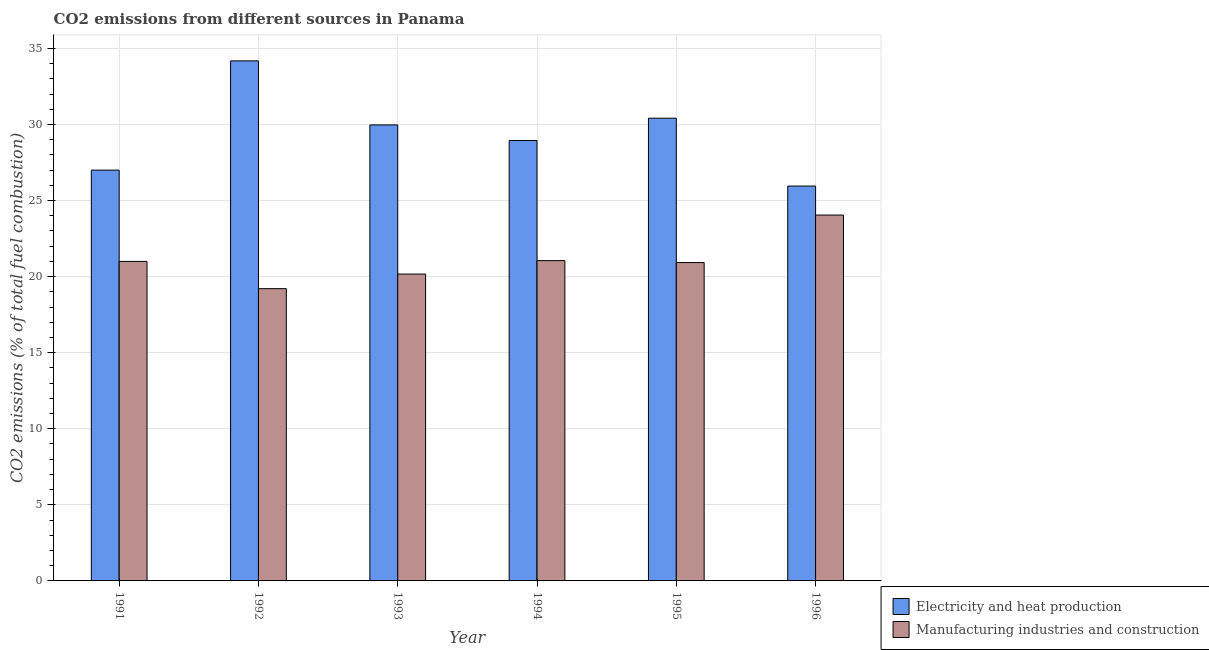Are the number of bars per tick equal to the number of legend labels?
Your answer should be very brief. Yes. Are the number of bars on each tick of the X-axis equal?
Ensure brevity in your answer.  Yes. What is the label of the 5th group of bars from the left?
Give a very brief answer. 1995. In how many cases, is the number of bars for a given year not equal to the number of legend labels?
Provide a short and direct response. 0. What is the co2 emissions due to electricity and heat production in 1991?
Provide a succinct answer. 27. Across all years, what is the maximum co2 emissions due to manufacturing industries?
Your answer should be very brief. 24.05. Across all years, what is the minimum co2 emissions due to electricity and heat production?
Offer a very short reply. 25.95. In which year was the co2 emissions due to manufacturing industries maximum?
Make the answer very short. 1996. What is the total co2 emissions due to manufacturing industries in the graph?
Ensure brevity in your answer.  126.4. What is the difference between the co2 emissions due to electricity and heat production in 1991 and that in 1993?
Keep it short and to the point. -2.97. What is the difference between the co2 emissions due to electricity and heat production in 1991 and the co2 emissions due to manufacturing industries in 1995?
Ensure brevity in your answer.  -3.41. What is the average co2 emissions due to manufacturing industries per year?
Make the answer very short. 21.07. In the year 1992, what is the difference between the co2 emissions due to electricity and heat production and co2 emissions due to manufacturing industries?
Give a very brief answer. 0. What is the ratio of the co2 emissions due to manufacturing industries in 1991 to that in 1995?
Offer a terse response. 1. What is the difference between the highest and the second highest co2 emissions due to manufacturing industries?
Ensure brevity in your answer.  2.99. What is the difference between the highest and the lowest co2 emissions due to manufacturing industries?
Offer a terse response. 4.84. In how many years, is the co2 emissions due to electricity and heat production greater than the average co2 emissions due to electricity and heat production taken over all years?
Keep it short and to the point. 3. What does the 1st bar from the left in 1993 represents?
Make the answer very short. Electricity and heat production. What does the 2nd bar from the right in 1991 represents?
Offer a very short reply. Electricity and heat production. How many bars are there?
Ensure brevity in your answer.  12. How many years are there in the graph?
Your answer should be compact. 6. What is the difference between two consecutive major ticks on the Y-axis?
Provide a short and direct response. 5. Are the values on the major ticks of Y-axis written in scientific E-notation?
Keep it short and to the point. No. Does the graph contain any zero values?
Your answer should be compact. No. Where does the legend appear in the graph?
Offer a terse response. Bottom right. How many legend labels are there?
Provide a short and direct response. 2. What is the title of the graph?
Make the answer very short. CO2 emissions from different sources in Panama. Does "Primary school" appear as one of the legend labels in the graph?
Ensure brevity in your answer.  No. What is the label or title of the X-axis?
Provide a short and direct response. Year. What is the label or title of the Y-axis?
Give a very brief answer. CO2 emissions (% of total fuel combustion). What is the CO2 emissions (% of total fuel combustion) of Electricity and heat production in 1991?
Keep it short and to the point. 27. What is the CO2 emissions (% of total fuel combustion) in Electricity and heat production in 1992?
Your answer should be compact. 34.18. What is the CO2 emissions (% of total fuel combustion) in Manufacturing industries and construction in 1992?
Offer a very short reply. 19.21. What is the CO2 emissions (% of total fuel combustion) of Electricity and heat production in 1993?
Provide a short and direct response. 29.97. What is the CO2 emissions (% of total fuel combustion) of Manufacturing industries and construction in 1993?
Keep it short and to the point. 20.17. What is the CO2 emissions (% of total fuel combustion) in Electricity and heat production in 1994?
Your response must be concise. 28.95. What is the CO2 emissions (% of total fuel combustion) in Manufacturing industries and construction in 1994?
Provide a succinct answer. 21.05. What is the CO2 emissions (% of total fuel combustion) in Electricity and heat production in 1995?
Ensure brevity in your answer.  30.41. What is the CO2 emissions (% of total fuel combustion) of Manufacturing industries and construction in 1995?
Your answer should be compact. 20.92. What is the CO2 emissions (% of total fuel combustion) of Electricity and heat production in 1996?
Your answer should be very brief. 25.95. What is the CO2 emissions (% of total fuel combustion) of Manufacturing industries and construction in 1996?
Give a very brief answer. 24.05. Across all years, what is the maximum CO2 emissions (% of total fuel combustion) of Electricity and heat production?
Your answer should be compact. 34.18. Across all years, what is the maximum CO2 emissions (% of total fuel combustion) in Manufacturing industries and construction?
Offer a terse response. 24.05. Across all years, what is the minimum CO2 emissions (% of total fuel combustion) of Electricity and heat production?
Your answer should be very brief. 25.95. Across all years, what is the minimum CO2 emissions (% of total fuel combustion) of Manufacturing industries and construction?
Give a very brief answer. 19.21. What is the total CO2 emissions (% of total fuel combustion) of Electricity and heat production in the graph?
Provide a succinct answer. 176.47. What is the total CO2 emissions (% of total fuel combustion) in Manufacturing industries and construction in the graph?
Your response must be concise. 126.4. What is the difference between the CO2 emissions (% of total fuel combustion) in Electricity and heat production in 1991 and that in 1992?
Your answer should be very brief. -7.18. What is the difference between the CO2 emissions (% of total fuel combustion) in Manufacturing industries and construction in 1991 and that in 1992?
Offer a very short reply. 1.79. What is the difference between the CO2 emissions (% of total fuel combustion) of Electricity and heat production in 1991 and that in 1993?
Keep it short and to the point. -2.97. What is the difference between the CO2 emissions (% of total fuel combustion) of Manufacturing industries and construction in 1991 and that in 1993?
Provide a succinct answer. 0.83. What is the difference between the CO2 emissions (% of total fuel combustion) of Electricity and heat production in 1991 and that in 1994?
Provide a succinct answer. -1.95. What is the difference between the CO2 emissions (% of total fuel combustion) of Manufacturing industries and construction in 1991 and that in 1994?
Offer a terse response. -0.05. What is the difference between the CO2 emissions (% of total fuel combustion) of Electricity and heat production in 1991 and that in 1995?
Your answer should be compact. -3.41. What is the difference between the CO2 emissions (% of total fuel combustion) in Manufacturing industries and construction in 1991 and that in 1995?
Give a very brief answer. 0.08. What is the difference between the CO2 emissions (% of total fuel combustion) of Electricity and heat production in 1991 and that in 1996?
Offer a terse response. 1.05. What is the difference between the CO2 emissions (% of total fuel combustion) of Manufacturing industries and construction in 1991 and that in 1996?
Provide a short and direct response. -3.05. What is the difference between the CO2 emissions (% of total fuel combustion) of Electricity and heat production in 1992 and that in 1993?
Give a very brief answer. 4.21. What is the difference between the CO2 emissions (% of total fuel combustion) of Manufacturing industries and construction in 1992 and that in 1993?
Keep it short and to the point. -0.96. What is the difference between the CO2 emissions (% of total fuel combustion) in Electricity and heat production in 1992 and that in 1994?
Your answer should be compact. 5.23. What is the difference between the CO2 emissions (% of total fuel combustion) in Manufacturing industries and construction in 1992 and that in 1994?
Ensure brevity in your answer.  -1.84. What is the difference between the CO2 emissions (% of total fuel combustion) in Electricity and heat production in 1992 and that in 1995?
Keep it short and to the point. 3.77. What is the difference between the CO2 emissions (% of total fuel combustion) of Manufacturing industries and construction in 1992 and that in 1995?
Ensure brevity in your answer.  -1.72. What is the difference between the CO2 emissions (% of total fuel combustion) of Electricity and heat production in 1992 and that in 1996?
Your response must be concise. 8.23. What is the difference between the CO2 emissions (% of total fuel combustion) in Manufacturing industries and construction in 1992 and that in 1996?
Offer a terse response. -4.84. What is the difference between the CO2 emissions (% of total fuel combustion) in Electricity and heat production in 1993 and that in 1994?
Offer a terse response. 1.02. What is the difference between the CO2 emissions (% of total fuel combustion) of Manufacturing industries and construction in 1993 and that in 1994?
Offer a terse response. -0.88. What is the difference between the CO2 emissions (% of total fuel combustion) of Electricity and heat production in 1993 and that in 1995?
Your answer should be very brief. -0.44. What is the difference between the CO2 emissions (% of total fuel combustion) of Manufacturing industries and construction in 1993 and that in 1995?
Your response must be concise. -0.76. What is the difference between the CO2 emissions (% of total fuel combustion) of Electricity and heat production in 1993 and that in 1996?
Your answer should be very brief. 4.02. What is the difference between the CO2 emissions (% of total fuel combustion) of Manufacturing industries and construction in 1993 and that in 1996?
Ensure brevity in your answer.  -3.88. What is the difference between the CO2 emissions (% of total fuel combustion) in Electricity and heat production in 1994 and that in 1995?
Make the answer very short. -1.47. What is the difference between the CO2 emissions (% of total fuel combustion) of Manufacturing industries and construction in 1994 and that in 1995?
Offer a terse response. 0.13. What is the difference between the CO2 emissions (% of total fuel combustion) of Electricity and heat production in 1994 and that in 1996?
Your answer should be compact. 3. What is the difference between the CO2 emissions (% of total fuel combustion) in Manufacturing industries and construction in 1994 and that in 1996?
Keep it short and to the point. -3. What is the difference between the CO2 emissions (% of total fuel combustion) in Electricity and heat production in 1995 and that in 1996?
Offer a very short reply. 4.46. What is the difference between the CO2 emissions (% of total fuel combustion) in Manufacturing industries and construction in 1995 and that in 1996?
Provide a short and direct response. -3.12. What is the difference between the CO2 emissions (% of total fuel combustion) in Electricity and heat production in 1991 and the CO2 emissions (% of total fuel combustion) in Manufacturing industries and construction in 1992?
Provide a short and direct response. 7.79. What is the difference between the CO2 emissions (% of total fuel combustion) of Electricity and heat production in 1991 and the CO2 emissions (% of total fuel combustion) of Manufacturing industries and construction in 1993?
Your answer should be compact. 6.83. What is the difference between the CO2 emissions (% of total fuel combustion) of Electricity and heat production in 1991 and the CO2 emissions (% of total fuel combustion) of Manufacturing industries and construction in 1994?
Your answer should be compact. 5.95. What is the difference between the CO2 emissions (% of total fuel combustion) of Electricity and heat production in 1991 and the CO2 emissions (% of total fuel combustion) of Manufacturing industries and construction in 1995?
Your response must be concise. 6.08. What is the difference between the CO2 emissions (% of total fuel combustion) in Electricity and heat production in 1991 and the CO2 emissions (% of total fuel combustion) in Manufacturing industries and construction in 1996?
Provide a succinct answer. 2.95. What is the difference between the CO2 emissions (% of total fuel combustion) in Electricity and heat production in 1992 and the CO2 emissions (% of total fuel combustion) in Manufacturing industries and construction in 1993?
Keep it short and to the point. 14.01. What is the difference between the CO2 emissions (% of total fuel combustion) in Electricity and heat production in 1992 and the CO2 emissions (% of total fuel combustion) in Manufacturing industries and construction in 1994?
Your answer should be very brief. 13.13. What is the difference between the CO2 emissions (% of total fuel combustion) of Electricity and heat production in 1992 and the CO2 emissions (% of total fuel combustion) of Manufacturing industries and construction in 1995?
Give a very brief answer. 13.26. What is the difference between the CO2 emissions (% of total fuel combustion) of Electricity and heat production in 1992 and the CO2 emissions (% of total fuel combustion) of Manufacturing industries and construction in 1996?
Provide a short and direct response. 10.13. What is the difference between the CO2 emissions (% of total fuel combustion) of Electricity and heat production in 1993 and the CO2 emissions (% of total fuel combustion) of Manufacturing industries and construction in 1994?
Ensure brevity in your answer.  8.92. What is the difference between the CO2 emissions (% of total fuel combustion) of Electricity and heat production in 1993 and the CO2 emissions (% of total fuel combustion) of Manufacturing industries and construction in 1995?
Make the answer very short. 9.05. What is the difference between the CO2 emissions (% of total fuel combustion) in Electricity and heat production in 1993 and the CO2 emissions (% of total fuel combustion) in Manufacturing industries and construction in 1996?
Make the answer very short. 5.92. What is the difference between the CO2 emissions (% of total fuel combustion) in Electricity and heat production in 1994 and the CO2 emissions (% of total fuel combustion) in Manufacturing industries and construction in 1995?
Provide a succinct answer. 8.02. What is the difference between the CO2 emissions (% of total fuel combustion) in Electricity and heat production in 1994 and the CO2 emissions (% of total fuel combustion) in Manufacturing industries and construction in 1996?
Provide a succinct answer. 4.9. What is the difference between the CO2 emissions (% of total fuel combustion) of Electricity and heat production in 1995 and the CO2 emissions (% of total fuel combustion) of Manufacturing industries and construction in 1996?
Your answer should be very brief. 6.37. What is the average CO2 emissions (% of total fuel combustion) in Electricity and heat production per year?
Offer a very short reply. 29.41. What is the average CO2 emissions (% of total fuel combustion) of Manufacturing industries and construction per year?
Your answer should be compact. 21.07. In the year 1991, what is the difference between the CO2 emissions (% of total fuel combustion) in Electricity and heat production and CO2 emissions (% of total fuel combustion) in Manufacturing industries and construction?
Your answer should be compact. 6. In the year 1992, what is the difference between the CO2 emissions (% of total fuel combustion) in Electricity and heat production and CO2 emissions (% of total fuel combustion) in Manufacturing industries and construction?
Ensure brevity in your answer.  14.97. In the year 1993, what is the difference between the CO2 emissions (% of total fuel combustion) in Electricity and heat production and CO2 emissions (% of total fuel combustion) in Manufacturing industries and construction?
Provide a succinct answer. 9.8. In the year 1994, what is the difference between the CO2 emissions (% of total fuel combustion) in Electricity and heat production and CO2 emissions (% of total fuel combustion) in Manufacturing industries and construction?
Provide a short and direct response. 7.89. In the year 1995, what is the difference between the CO2 emissions (% of total fuel combustion) in Electricity and heat production and CO2 emissions (% of total fuel combustion) in Manufacturing industries and construction?
Offer a terse response. 9.49. In the year 1996, what is the difference between the CO2 emissions (% of total fuel combustion) in Electricity and heat production and CO2 emissions (% of total fuel combustion) in Manufacturing industries and construction?
Your response must be concise. 1.9. What is the ratio of the CO2 emissions (% of total fuel combustion) of Electricity and heat production in 1991 to that in 1992?
Offer a terse response. 0.79. What is the ratio of the CO2 emissions (% of total fuel combustion) of Manufacturing industries and construction in 1991 to that in 1992?
Ensure brevity in your answer.  1.09. What is the ratio of the CO2 emissions (% of total fuel combustion) in Electricity and heat production in 1991 to that in 1993?
Make the answer very short. 0.9. What is the ratio of the CO2 emissions (% of total fuel combustion) of Manufacturing industries and construction in 1991 to that in 1993?
Offer a very short reply. 1.04. What is the ratio of the CO2 emissions (% of total fuel combustion) of Electricity and heat production in 1991 to that in 1994?
Offer a very short reply. 0.93. What is the ratio of the CO2 emissions (% of total fuel combustion) of Electricity and heat production in 1991 to that in 1995?
Offer a very short reply. 0.89. What is the ratio of the CO2 emissions (% of total fuel combustion) of Manufacturing industries and construction in 1991 to that in 1995?
Your answer should be very brief. 1. What is the ratio of the CO2 emissions (% of total fuel combustion) in Electricity and heat production in 1991 to that in 1996?
Give a very brief answer. 1.04. What is the ratio of the CO2 emissions (% of total fuel combustion) of Manufacturing industries and construction in 1991 to that in 1996?
Ensure brevity in your answer.  0.87. What is the ratio of the CO2 emissions (% of total fuel combustion) in Electricity and heat production in 1992 to that in 1993?
Your response must be concise. 1.14. What is the ratio of the CO2 emissions (% of total fuel combustion) in Electricity and heat production in 1992 to that in 1994?
Provide a succinct answer. 1.18. What is the ratio of the CO2 emissions (% of total fuel combustion) in Manufacturing industries and construction in 1992 to that in 1994?
Provide a short and direct response. 0.91. What is the ratio of the CO2 emissions (% of total fuel combustion) in Electricity and heat production in 1992 to that in 1995?
Your answer should be very brief. 1.12. What is the ratio of the CO2 emissions (% of total fuel combustion) of Manufacturing industries and construction in 1992 to that in 1995?
Your answer should be compact. 0.92. What is the ratio of the CO2 emissions (% of total fuel combustion) of Electricity and heat production in 1992 to that in 1996?
Offer a very short reply. 1.32. What is the ratio of the CO2 emissions (% of total fuel combustion) of Manufacturing industries and construction in 1992 to that in 1996?
Your response must be concise. 0.8. What is the ratio of the CO2 emissions (% of total fuel combustion) of Electricity and heat production in 1993 to that in 1994?
Ensure brevity in your answer.  1.04. What is the ratio of the CO2 emissions (% of total fuel combustion) in Manufacturing industries and construction in 1993 to that in 1994?
Offer a terse response. 0.96. What is the ratio of the CO2 emissions (% of total fuel combustion) of Electricity and heat production in 1993 to that in 1995?
Your answer should be compact. 0.99. What is the ratio of the CO2 emissions (% of total fuel combustion) of Manufacturing industries and construction in 1993 to that in 1995?
Provide a short and direct response. 0.96. What is the ratio of the CO2 emissions (% of total fuel combustion) of Electricity and heat production in 1993 to that in 1996?
Provide a succinct answer. 1.15. What is the ratio of the CO2 emissions (% of total fuel combustion) of Manufacturing industries and construction in 1993 to that in 1996?
Offer a very short reply. 0.84. What is the ratio of the CO2 emissions (% of total fuel combustion) of Electricity and heat production in 1994 to that in 1995?
Your response must be concise. 0.95. What is the ratio of the CO2 emissions (% of total fuel combustion) of Manufacturing industries and construction in 1994 to that in 1995?
Ensure brevity in your answer.  1.01. What is the ratio of the CO2 emissions (% of total fuel combustion) of Electricity and heat production in 1994 to that in 1996?
Provide a short and direct response. 1.12. What is the ratio of the CO2 emissions (% of total fuel combustion) in Manufacturing industries and construction in 1994 to that in 1996?
Provide a short and direct response. 0.88. What is the ratio of the CO2 emissions (% of total fuel combustion) of Electricity and heat production in 1995 to that in 1996?
Ensure brevity in your answer.  1.17. What is the ratio of the CO2 emissions (% of total fuel combustion) of Manufacturing industries and construction in 1995 to that in 1996?
Make the answer very short. 0.87. What is the difference between the highest and the second highest CO2 emissions (% of total fuel combustion) of Electricity and heat production?
Provide a succinct answer. 3.77. What is the difference between the highest and the second highest CO2 emissions (% of total fuel combustion) in Manufacturing industries and construction?
Your answer should be compact. 3. What is the difference between the highest and the lowest CO2 emissions (% of total fuel combustion) in Electricity and heat production?
Keep it short and to the point. 8.23. What is the difference between the highest and the lowest CO2 emissions (% of total fuel combustion) of Manufacturing industries and construction?
Provide a succinct answer. 4.84. 